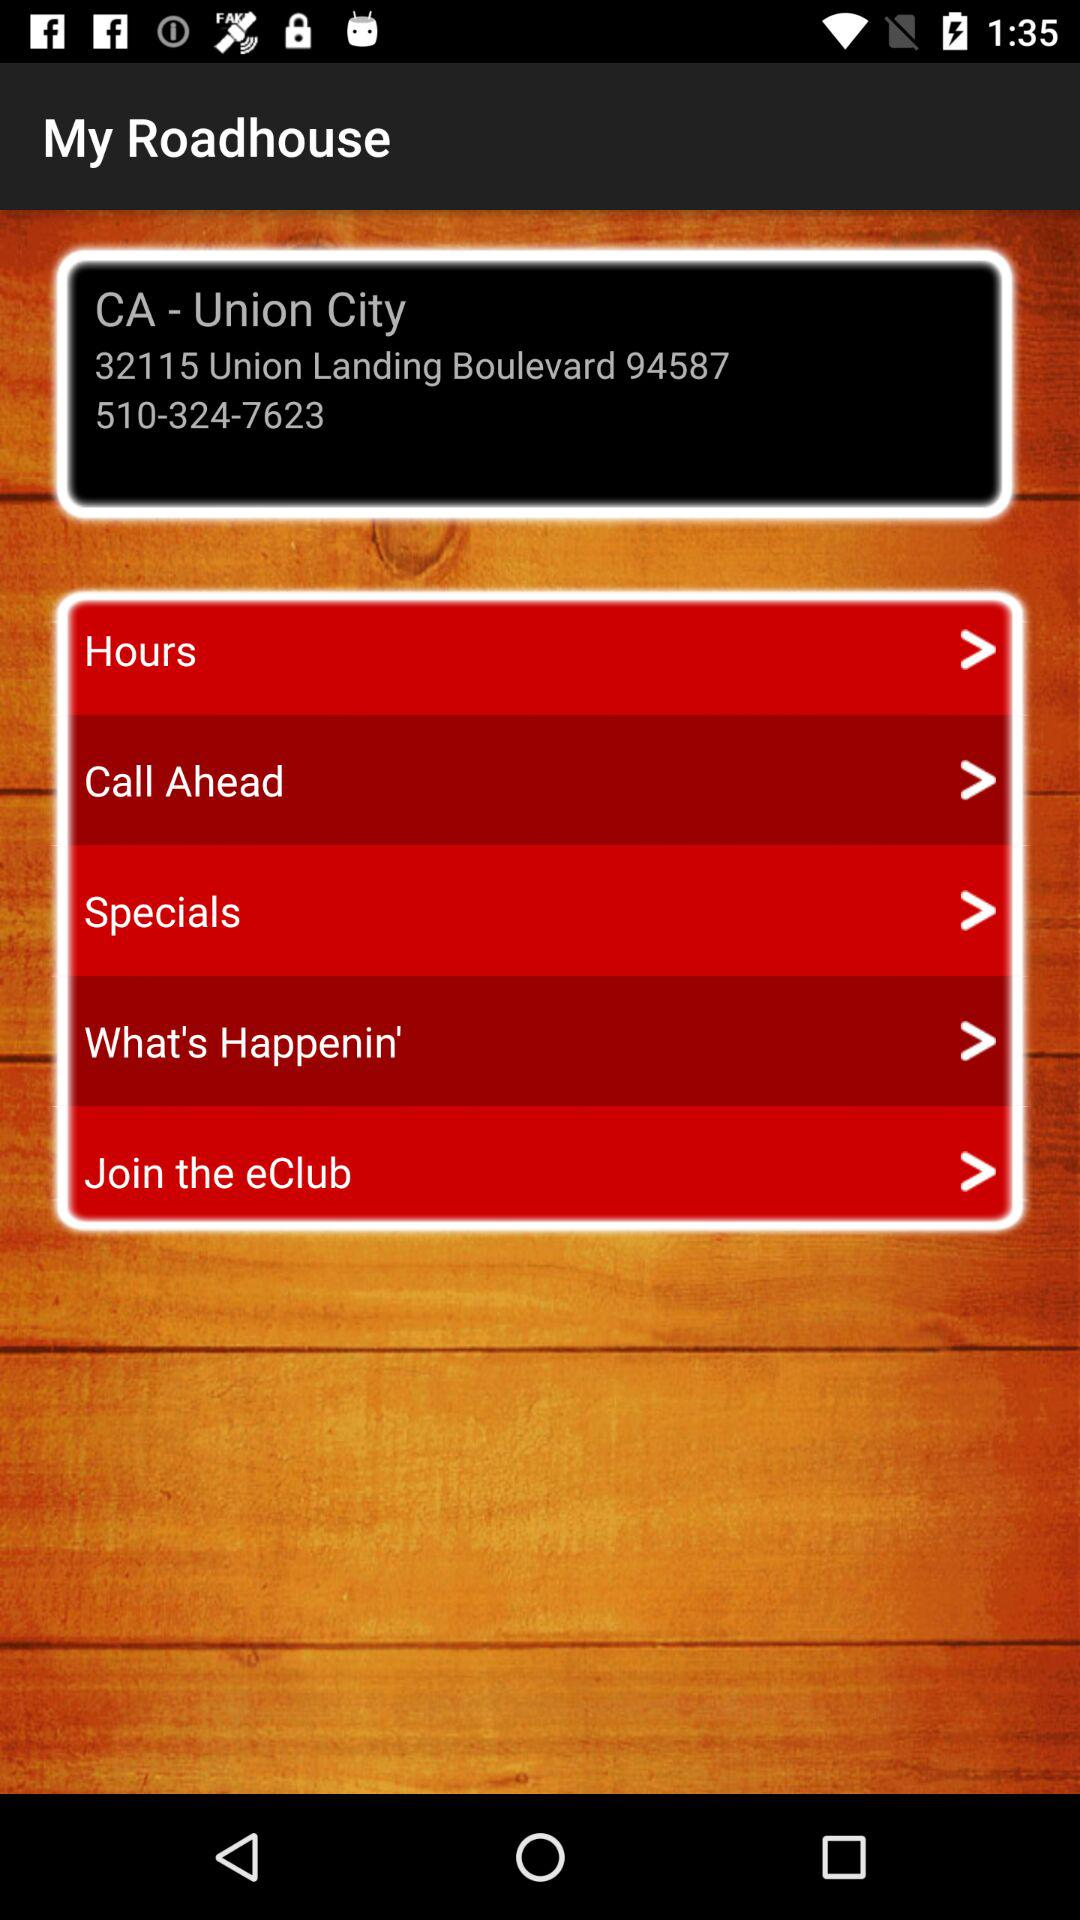What is the address? The address is 32115 Union Landing Boulevard, 94587. 